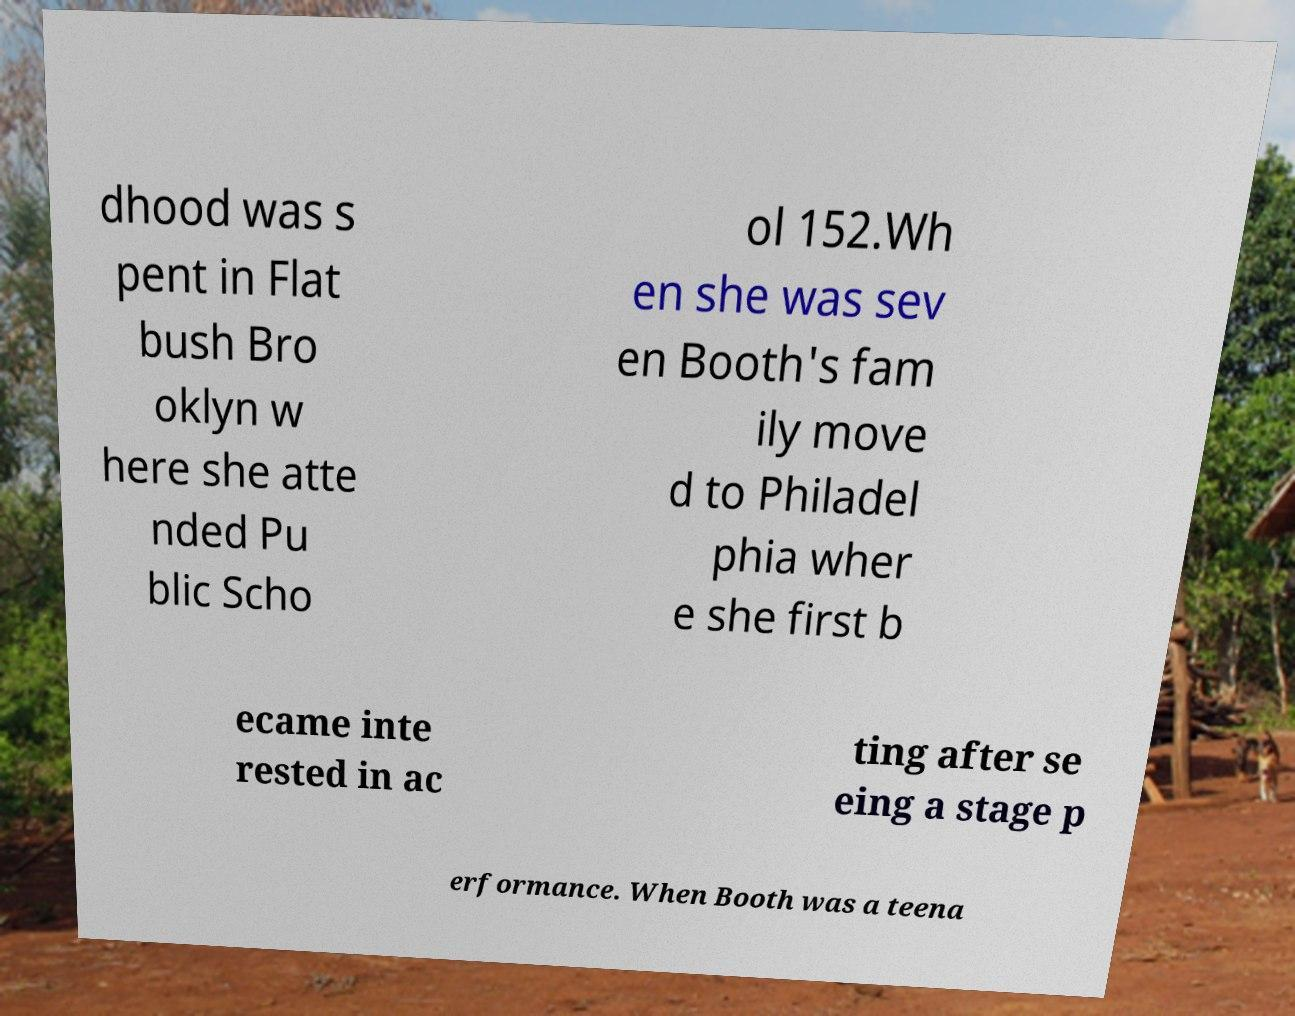I need the written content from this picture converted into text. Can you do that? dhood was s pent in Flat bush Bro oklyn w here she atte nded Pu blic Scho ol 152.Wh en she was sev en Booth's fam ily move d to Philadel phia wher e she first b ecame inte rested in ac ting after se eing a stage p erformance. When Booth was a teena 